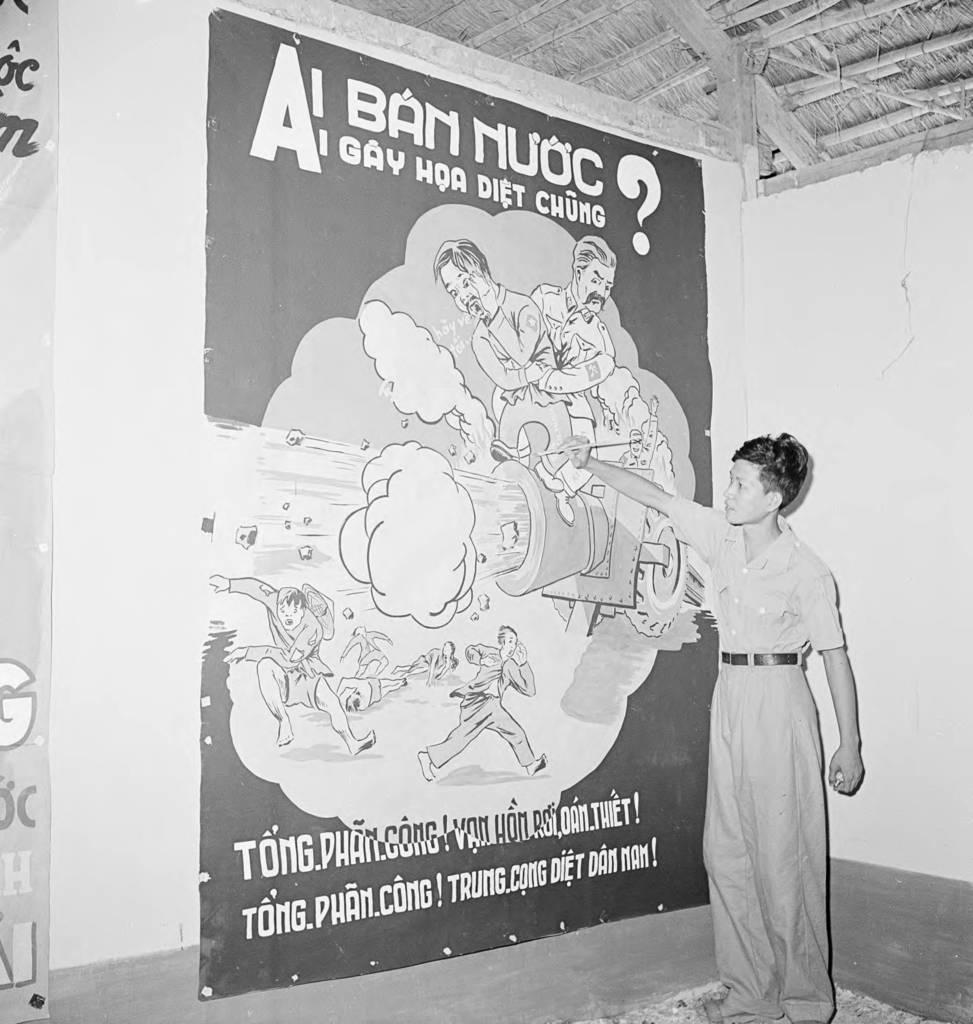What is the main subject of the image? There is a person standing in the image. Where is the person standing? The person is standing on the floor. What can be seen on the walls in the image? There are posters in the image. What type of images are on the posters? The poster contains cartoon images. Is there any text on the poster? Yes, text is written on the poster. What type of marble is visible on the floor in the image? There is no marble visible on the floor in the image; it is not mentioned in the provided facts. What is the rate of the person's movement in the image? The person is standing still in the image, so there is no rate of movement to determine. 